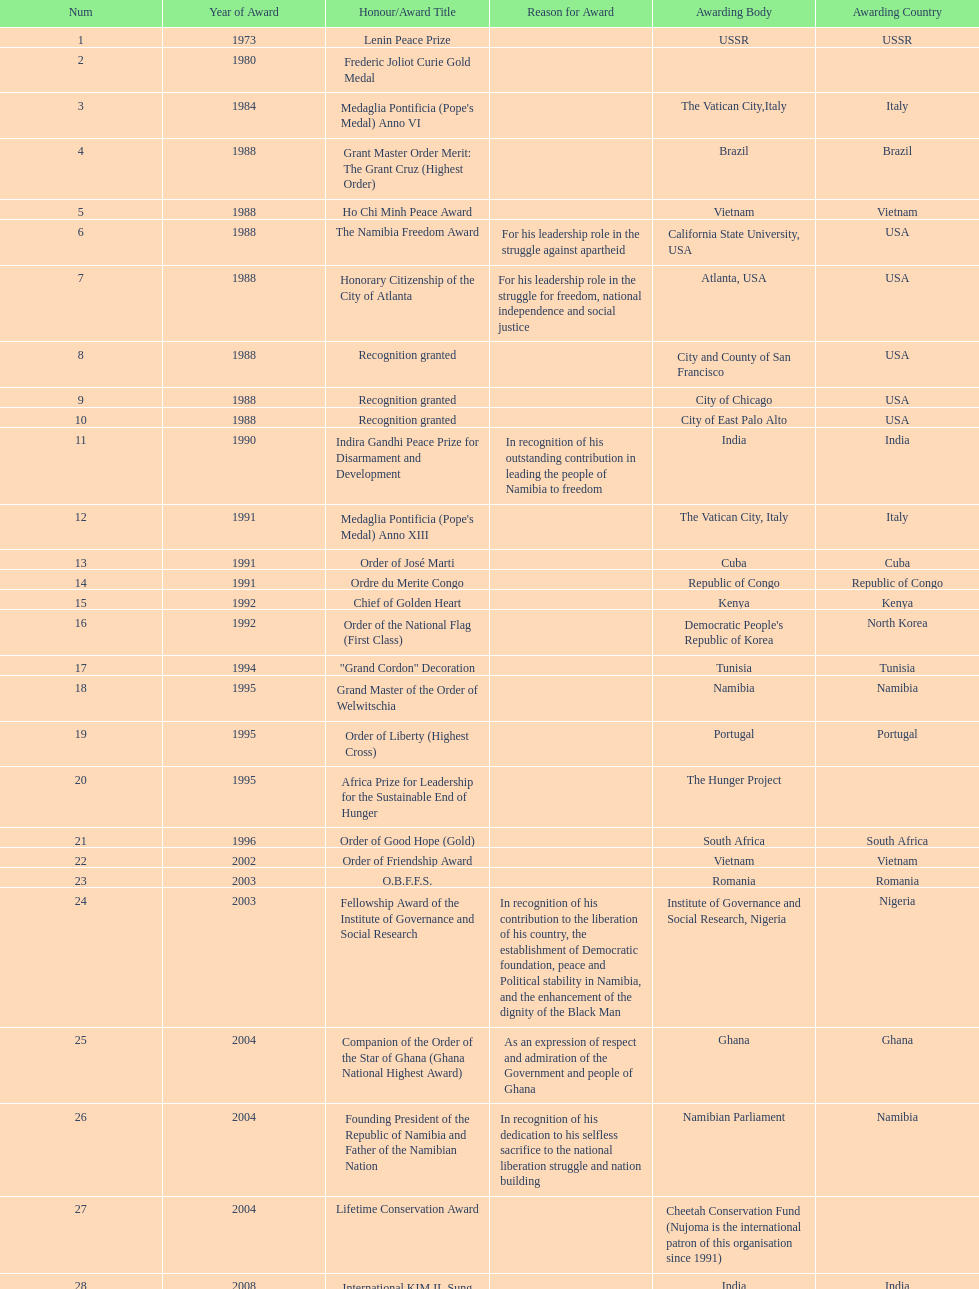What was the name of the honor/award title given after the international kim il sung prize certificate? Sir Seretse Khama SADC Meda. Write the full table. {'header': ['Num', 'Year of Award', 'Honour/Award Title', 'Reason for Award', 'Awarding Body', 'Awarding Country'], 'rows': [['1', '1973', 'Lenin Peace Prize', '', 'USSR', 'USSR'], ['2', '1980', 'Frederic Joliot Curie Gold Medal', '', '', ''], ['3', '1984', "Medaglia Pontificia (Pope's Medal) Anno VI", '', 'The Vatican City,Italy', 'Italy'], ['4', '1988', 'Grant Master Order Merit: The Grant Cruz (Highest Order)', '', 'Brazil', 'Brazil'], ['5', '1988', 'Ho Chi Minh Peace Award', '', 'Vietnam', 'Vietnam'], ['6', '1988', 'The Namibia Freedom Award', 'For his leadership role in the struggle against apartheid', 'California State University, USA', 'USA'], ['7', '1988', 'Honorary Citizenship of the City of Atlanta', 'For his leadership role in the struggle for freedom, national independence and social justice', 'Atlanta, USA', 'USA'], ['8', '1988', 'Recognition granted', '', 'City and County of San Francisco', 'USA'], ['9', '1988', 'Recognition granted', '', 'City of Chicago', 'USA'], ['10', '1988', 'Recognition granted', '', 'City of East Palo Alto', 'USA'], ['11', '1990', 'Indira Gandhi Peace Prize for Disarmament and Development', 'In recognition of his outstanding contribution in leading the people of Namibia to freedom', 'India', 'India'], ['12', '1991', "Medaglia Pontificia (Pope's Medal) Anno XIII", '', 'The Vatican City, Italy', 'Italy'], ['13', '1991', 'Order of José Marti', '', 'Cuba', 'Cuba'], ['14', '1991', 'Ordre du Merite Congo', '', 'Republic of Congo', 'Republic of Congo'], ['15', '1992', 'Chief of Golden Heart', '', 'Kenya', 'Kenya'], ['16', '1992', 'Order of the National Flag (First Class)', '', "Democratic People's Republic of Korea", 'North Korea'], ['17', '1994', '"Grand Cordon" Decoration', '', 'Tunisia', 'Tunisia'], ['18', '1995', 'Grand Master of the Order of Welwitschia', '', 'Namibia', 'Namibia'], ['19', '1995', 'Order of Liberty (Highest Cross)', '', 'Portugal', 'Portugal'], ['20', '1995', 'Africa Prize for Leadership for the Sustainable End of Hunger', '', 'The Hunger Project', ''], ['21', '1996', 'Order of Good Hope (Gold)', '', 'South Africa', 'South Africa'], ['22', '2002', 'Order of Friendship Award', '', 'Vietnam', 'Vietnam'], ['23', '2003', 'O.B.F.F.S.', '', 'Romania', 'Romania'], ['24', '2003', 'Fellowship Award of the Institute of Governance and Social Research', 'In recognition of his contribution to the liberation of his country, the establishment of Democratic foundation, peace and Political stability in Namibia, and the enhancement of the dignity of the Black Man', 'Institute of Governance and Social Research, Nigeria', 'Nigeria'], ['25', '2004', 'Companion of the Order of the Star of Ghana (Ghana National Highest Award)', 'As an expression of respect and admiration of the Government and people of Ghana', 'Ghana', 'Ghana'], ['26', '2004', 'Founding President of the Republic of Namibia and Father of the Namibian Nation', 'In recognition of his dedication to his selfless sacrifice to the national liberation struggle and nation building', 'Namibian Parliament', 'Namibia'], ['27', '2004', 'Lifetime Conservation Award', '', 'Cheetah Conservation Fund (Nujoma is the international patron of this organisation since 1991)', ''], ['28', '2008', 'International KIM IL Sung Prize Certificate', '', 'India', 'India'], ['29', '2010', 'Sir Seretse Khama SADC Meda', '', 'SADC', '']]} 